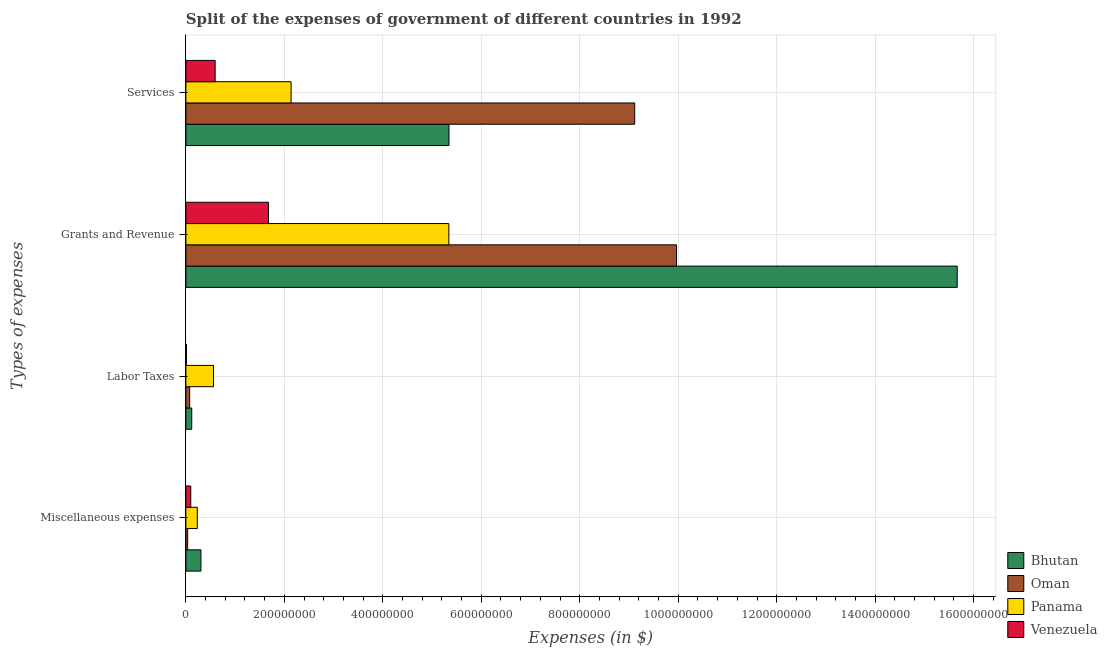How many different coloured bars are there?
Your response must be concise. 4. How many bars are there on the 3rd tick from the top?
Make the answer very short. 4. What is the label of the 2nd group of bars from the top?
Offer a terse response. Grants and Revenue. What is the amount spent on miscellaneous expenses in Bhutan?
Your answer should be compact. 3.06e+07. Across all countries, what is the maximum amount spent on labor taxes?
Give a very brief answer. 5.61e+07. Across all countries, what is the minimum amount spent on services?
Offer a terse response. 5.95e+07. In which country was the amount spent on labor taxes maximum?
Make the answer very short. Panama. In which country was the amount spent on services minimum?
Make the answer very short. Venezuela. What is the total amount spent on miscellaneous expenses in the graph?
Offer a terse response. 6.73e+07. What is the difference between the amount spent on miscellaneous expenses in Panama and that in Venezuela?
Provide a short and direct response. 1.33e+07. What is the difference between the amount spent on miscellaneous expenses in Venezuela and the amount spent on grants and revenue in Panama?
Ensure brevity in your answer.  -5.24e+08. What is the average amount spent on labor taxes per country?
Your answer should be very brief. 1.92e+07. What is the difference between the amount spent on grants and revenue and amount spent on labor taxes in Oman?
Provide a short and direct response. 9.89e+08. In how many countries, is the amount spent on labor taxes greater than 240000000 $?
Keep it short and to the point. 0. What is the ratio of the amount spent on services in Oman to that in Bhutan?
Provide a short and direct response. 1.71. Is the amount spent on grants and revenue in Bhutan less than that in Venezuela?
Keep it short and to the point. No. Is the difference between the amount spent on grants and revenue in Oman and Panama greater than the difference between the amount spent on miscellaneous expenses in Oman and Panama?
Provide a succinct answer. Yes. What is the difference between the highest and the second highest amount spent on labor taxes?
Keep it short and to the point. 4.42e+07. What is the difference between the highest and the lowest amount spent on labor taxes?
Offer a very short reply. 5.49e+07. Is the sum of the amount spent on grants and revenue in Venezuela and Panama greater than the maximum amount spent on labor taxes across all countries?
Your answer should be very brief. Yes. What does the 2nd bar from the top in Services represents?
Your response must be concise. Panama. What does the 1st bar from the bottom in Labor Taxes represents?
Give a very brief answer. Bhutan. Is it the case that in every country, the sum of the amount spent on miscellaneous expenses and amount spent on labor taxes is greater than the amount spent on grants and revenue?
Your answer should be compact. No. How many bars are there?
Make the answer very short. 16. How many countries are there in the graph?
Your response must be concise. 4. Are the values on the major ticks of X-axis written in scientific E-notation?
Make the answer very short. No. Does the graph contain any zero values?
Provide a succinct answer. No. Where does the legend appear in the graph?
Your response must be concise. Bottom right. How many legend labels are there?
Ensure brevity in your answer.  4. How are the legend labels stacked?
Keep it short and to the point. Vertical. What is the title of the graph?
Your answer should be very brief. Split of the expenses of government of different countries in 1992. What is the label or title of the X-axis?
Ensure brevity in your answer.  Expenses (in $). What is the label or title of the Y-axis?
Provide a succinct answer. Types of expenses. What is the Expenses (in $) of Bhutan in Miscellaneous expenses?
Provide a succinct answer. 3.06e+07. What is the Expenses (in $) in Oman in Miscellaneous expenses?
Your response must be concise. 3.60e+06. What is the Expenses (in $) of Panama in Miscellaneous expenses?
Your answer should be very brief. 2.32e+07. What is the Expenses (in $) in Venezuela in Miscellaneous expenses?
Offer a very short reply. 9.93e+06. What is the Expenses (in $) in Bhutan in Labor Taxes?
Your response must be concise. 1.19e+07. What is the Expenses (in $) in Oman in Labor Taxes?
Your answer should be compact. 7.70e+06. What is the Expenses (in $) of Panama in Labor Taxes?
Offer a terse response. 5.61e+07. What is the Expenses (in $) in Venezuela in Labor Taxes?
Your answer should be compact. 1.15e+06. What is the Expenses (in $) in Bhutan in Grants and Revenue?
Provide a short and direct response. 1.57e+09. What is the Expenses (in $) in Oman in Grants and Revenue?
Offer a terse response. 9.96e+08. What is the Expenses (in $) of Panama in Grants and Revenue?
Your answer should be very brief. 5.34e+08. What is the Expenses (in $) in Venezuela in Grants and Revenue?
Make the answer very short. 1.68e+08. What is the Expenses (in $) in Bhutan in Services?
Provide a succinct answer. 5.34e+08. What is the Expenses (in $) of Oman in Services?
Give a very brief answer. 9.12e+08. What is the Expenses (in $) of Panama in Services?
Ensure brevity in your answer.  2.14e+08. What is the Expenses (in $) of Venezuela in Services?
Your response must be concise. 5.95e+07. Across all Types of expenses, what is the maximum Expenses (in $) of Bhutan?
Your answer should be compact. 1.57e+09. Across all Types of expenses, what is the maximum Expenses (in $) in Oman?
Give a very brief answer. 9.96e+08. Across all Types of expenses, what is the maximum Expenses (in $) in Panama?
Provide a short and direct response. 5.34e+08. Across all Types of expenses, what is the maximum Expenses (in $) of Venezuela?
Ensure brevity in your answer.  1.68e+08. Across all Types of expenses, what is the minimum Expenses (in $) of Bhutan?
Offer a terse response. 1.19e+07. Across all Types of expenses, what is the minimum Expenses (in $) of Oman?
Ensure brevity in your answer.  3.60e+06. Across all Types of expenses, what is the minimum Expenses (in $) of Panama?
Make the answer very short. 2.32e+07. Across all Types of expenses, what is the minimum Expenses (in $) in Venezuela?
Make the answer very short. 1.15e+06. What is the total Expenses (in $) in Bhutan in the graph?
Make the answer very short. 2.14e+09. What is the total Expenses (in $) in Oman in the graph?
Give a very brief answer. 1.92e+09. What is the total Expenses (in $) in Panama in the graph?
Your response must be concise. 8.27e+08. What is the total Expenses (in $) of Venezuela in the graph?
Keep it short and to the point. 2.38e+08. What is the difference between the Expenses (in $) in Bhutan in Miscellaneous expenses and that in Labor Taxes?
Your answer should be very brief. 1.87e+07. What is the difference between the Expenses (in $) in Oman in Miscellaneous expenses and that in Labor Taxes?
Your answer should be compact. -4.10e+06. What is the difference between the Expenses (in $) of Panama in Miscellaneous expenses and that in Labor Taxes?
Make the answer very short. -3.29e+07. What is the difference between the Expenses (in $) in Venezuela in Miscellaneous expenses and that in Labor Taxes?
Your answer should be compact. 8.78e+06. What is the difference between the Expenses (in $) of Bhutan in Miscellaneous expenses and that in Grants and Revenue?
Keep it short and to the point. -1.54e+09. What is the difference between the Expenses (in $) in Oman in Miscellaneous expenses and that in Grants and Revenue?
Keep it short and to the point. -9.93e+08. What is the difference between the Expenses (in $) in Panama in Miscellaneous expenses and that in Grants and Revenue?
Make the answer very short. -5.11e+08. What is the difference between the Expenses (in $) of Venezuela in Miscellaneous expenses and that in Grants and Revenue?
Ensure brevity in your answer.  -1.58e+08. What is the difference between the Expenses (in $) of Bhutan in Miscellaneous expenses and that in Services?
Make the answer very short. -5.04e+08. What is the difference between the Expenses (in $) in Oman in Miscellaneous expenses and that in Services?
Provide a short and direct response. -9.08e+08. What is the difference between the Expenses (in $) of Panama in Miscellaneous expenses and that in Services?
Make the answer very short. -1.90e+08. What is the difference between the Expenses (in $) in Venezuela in Miscellaneous expenses and that in Services?
Keep it short and to the point. -4.95e+07. What is the difference between the Expenses (in $) in Bhutan in Labor Taxes and that in Grants and Revenue?
Offer a very short reply. -1.55e+09. What is the difference between the Expenses (in $) of Oman in Labor Taxes and that in Grants and Revenue?
Make the answer very short. -9.89e+08. What is the difference between the Expenses (in $) of Panama in Labor Taxes and that in Grants and Revenue?
Provide a short and direct response. -4.78e+08. What is the difference between the Expenses (in $) in Venezuela in Labor Taxes and that in Grants and Revenue?
Ensure brevity in your answer.  -1.67e+08. What is the difference between the Expenses (in $) of Bhutan in Labor Taxes and that in Services?
Your answer should be very brief. -5.22e+08. What is the difference between the Expenses (in $) in Oman in Labor Taxes and that in Services?
Your answer should be compact. -9.04e+08. What is the difference between the Expenses (in $) of Panama in Labor Taxes and that in Services?
Ensure brevity in your answer.  -1.58e+08. What is the difference between the Expenses (in $) of Venezuela in Labor Taxes and that in Services?
Your answer should be very brief. -5.83e+07. What is the difference between the Expenses (in $) of Bhutan in Grants and Revenue and that in Services?
Keep it short and to the point. 1.03e+09. What is the difference between the Expenses (in $) in Oman in Grants and Revenue and that in Services?
Your answer should be very brief. 8.49e+07. What is the difference between the Expenses (in $) of Panama in Grants and Revenue and that in Services?
Your response must be concise. 3.20e+08. What is the difference between the Expenses (in $) in Venezuela in Grants and Revenue and that in Services?
Offer a terse response. 1.08e+08. What is the difference between the Expenses (in $) in Bhutan in Miscellaneous expenses and the Expenses (in $) in Oman in Labor Taxes?
Keep it short and to the point. 2.29e+07. What is the difference between the Expenses (in $) in Bhutan in Miscellaneous expenses and the Expenses (in $) in Panama in Labor Taxes?
Offer a very short reply. -2.55e+07. What is the difference between the Expenses (in $) in Bhutan in Miscellaneous expenses and the Expenses (in $) in Venezuela in Labor Taxes?
Your answer should be very brief. 2.94e+07. What is the difference between the Expenses (in $) of Oman in Miscellaneous expenses and the Expenses (in $) of Panama in Labor Taxes?
Your response must be concise. -5.25e+07. What is the difference between the Expenses (in $) in Oman in Miscellaneous expenses and the Expenses (in $) in Venezuela in Labor Taxes?
Give a very brief answer. 2.45e+06. What is the difference between the Expenses (in $) in Panama in Miscellaneous expenses and the Expenses (in $) in Venezuela in Labor Taxes?
Make the answer very short. 2.20e+07. What is the difference between the Expenses (in $) of Bhutan in Miscellaneous expenses and the Expenses (in $) of Oman in Grants and Revenue?
Offer a very short reply. -9.66e+08. What is the difference between the Expenses (in $) of Bhutan in Miscellaneous expenses and the Expenses (in $) of Panama in Grants and Revenue?
Provide a short and direct response. -5.04e+08. What is the difference between the Expenses (in $) in Bhutan in Miscellaneous expenses and the Expenses (in $) in Venezuela in Grants and Revenue?
Provide a short and direct response. -1.37e+08. What is the difference between the Expenses (in $) of Oman in Miscellaneous expenses and the Expenses (in $) of Panama in Grants and Revenue?
Provide a succinct answer. -5.30e+08. What is the difference between the Expenses (in $) in Oman in Miscellaneous expenses and the Expenses (in $) in Venezuela in Grants and Revenue?
Offer a very short reply. -1.64e+08. What is the difference between the Expenses (in $) in Panama in Miscellaneous expenses and the Expenses (in $) in Venezuela in Grants and Revenue?
Provide a short and direct response. -1.45e+08. What is the difference between the Expenses (in $) in Bhutan in Miscellaneous expenses and the Expenses (in $) in Oman in Services?
Provide a succinct answer. -8.81e+08. What is the difference between the Expenses (in $) in Bhutan in Miscellaneous expenses and the Expenses (in $) in Panama in Services?
Provide a short and direct response. -1.83e+08. What is the difference between the Expenses (in $) in Bhutan in Miscellaneous expenses and the Expenses (in $) in Venezuela in Services?
Your response must be concise. -2.89e+07. What is the difference between the Expenses (in $) in Oman in Miscellaneous expenses and the Expenses (in $) in Panama in Services?
Ensure brevity in your answer.  -2.10e+08. What is the difference between the Expenses (in $) of Oman in Miscellaneous expenses and the Expenses (in $) of Venezuela in Services?
Your response must be concise. -5.59e+07. What is the difference between the Expenses (in $) in Panama in Miscellaneous expenses and the Expenses (in $) in Venezuela in Services?
Provide a succinct answer. -3.63e+07. What is the difference between the Expenses (in $) of Bhutan in Labor Taxes and the Expenses (in $) of Oman in Grants and Revenue?
Ensure brevity in your answer.  -9.85e+08. What is the difference between the Expenses (in $) in Bhutan in Labor Taxes and the Expenses (in $) in Panama in Grants and Revenue?
Your answer should be compact. -5.22e+08. What is the difference between the Expenses (in $) in Bhutan in Labor Taxes and the Expenses (in $) in Venezuela in Grants and Revenue?
Offer a very short reply. -1.56e+08. What is the difference between the Expenses (in $) of Oman in Labor Taxes and the Expenses (in $) of Panama in Grants and Revenue?
Ensure brevity in your answer.  -5.26e+08. What is the difference between the Expenses (in $) in Oman in Labor Taxes and the Expenses (in $) in Venezuela in Grants and Revenue?
Offer a terse response. -1.60e+08. What is the difference between the Expenses (in $) of Panama in Labor Taxes and the Expenses (in $) of Venezuela in Grants and Revenue?
Give a very brief answer. -1.12e+08. What is the difference between the Expenses (in $) of Bhutan in Labor Taxes and the Expenses (in $) of Oman in Services?
Give a very brief answer. -9.00e+08. What is the difference between the Expenses (in $) in Bhutan in Labor Taxes and the Expenses (in $) in Panama in Services?
Make the answer very short. -2.02e+08. What is the difference between the Expenses (in $) of Bhutan in Labor Taxes and the Expenses (in $) of Venezuela in Services?
Make the answer very short. -4.76e+07. What is the difference between the Expenses (in $) of Oman in Labor Taxes and the Expenses (in $) of Panama in Services?
Your answer should be very brief. -2.06e+08. What is the difference between the Expenses (in $) in Oman in Labor Taxes and the Expenses (in $) in Venezuela in Services?
Offer a very short reply. -5.18e+07. What is the difference between the Expenses (in $) of Panama in Labor Taxes and the Expenses (in $) of Venezuela in Services?
Offer a terse response. -3.36e+06. What is the difference between the Expenses (in $) in Bhutan in Grants and Revenue and the Expenses (in $) in Oman in Services?
Your answer should be compact. 6.55e+08. What is the difference between the Expenses (in $) of Bhutan in Grants and Revenue and the Expenses (in $) of Panama in Services?
Keep it short and to the point. 1.35e+09. What is the difference between the Expenses (in $) of Bhutan in Grants and Revenue and the Expenses (in $) of Venezuela in Services?
Ensure brevity in your answer.  1.51e+09. What is the difference between the Expenses (in $) in Oman in Grants and Revenue and the Expenses (in $) in Panama in Services?
Keep it short and to the point. 7.83e+08. What is the difference between the Expenses (in $) of Oman in Grants and Revenue and the Expenses (in $) of Venezuela in Services?
Give a very brief answer. 9.37e+08. What is the difference between the Expenses (in $) of Panama in Grants and Revenue and the Expenses (in $) of Venezuela in Services?
Make the answer very short. 4.75e+08. What is the average Expenses (in $) of Bhutan per Types of expenses?
Make the answer very short. 5.36e+08. What is the average Expenses (in $) of Oman per Types of expenses?
Provide a short and direct response. 4.80e+08. What is the average Expenses (in $) of Panama per Types of expenses?
Offer a terse response. 2.07e+08. What is the average Expenses (in $) of Venezuela per Types of expenses?
Your answer should be very brief. 5.96e+07. What is the difference between the Expenses (in $) in Bhutan and Expenses (in $) in Oman in Miscellaneous expenses?
Offer a very short reply. 2.70e+07. What is the difference between the Expenses (in $) of Bhutan and Expenses (in $) of Panama in Miscellaneous expenses?
Offer a terse response. 7.40e+06. What is the difference between the Expenses (in $) in Bhutan and Expenses (in $) in Venezuela in Miscellaneous expenses?
Give a very brief answer. 2.07e+07. What is the difference between the Expenses (in $) in Oman and Expenses (in $) in Panama in Miscellaneous expenses?
Keep it short and to the point. -1.96e+07. What is the difference between the Expenses (in $) in Oman and Expenses (in $) in Venezuela in Miscellaneous expenses?
Your response must be concise. -6.33e+06. What is the difference between the Expenses (in $) in Panama and Expenses (in $) in Venezuela in Miscellaneous expenses?
Keep it short and to the point. 1.33e+07. What is the difference between the Expenses (in $) in Bhutan and Expenses (in $) in Oman in Labor Taxes?
Offer a terse response. 4.20e+06. What is the difference between the Expenses (in $) in Bhutan and Expenses (in $) in Panama in Labor Taxes?
Offer a very short reply. -4.42e+07. What is the difference between the Expenses (in $) of Bhutan and Expenses (in $) of Venezuela in Labor Taxes?
Ensure brevity in your answer.  1.07e+07. What is the difference between the Expenses (in $) of Oman and Expenses (in $) of Panama in Labor Taxes?
Offer a terse response. -4.84e+07. What is the difference between the Expenses (in $) of Oman and Expenses (in $) of Venezuela in Labor Taxes?
Offer a very short reply. 6.55e+06. What is the difference between the Expenses (in $) of Panama and Expenses (in $) of Venezuela in Labor Taxes?
Your response must be concise. 5.49e+07. What is the difference between the Expenses (in $) in Bhutan and Expenses (in $) in Oman in Grants and Revenue?
Your answer should be very brief. 5.70e+08. What is the difference between the Expenses (in $) in Bhutan and Expenses (in $) in Panama in Grants and Revenue?
Your answer should be very brief. 1.03e+09. What is the difference between the Expenses (in $) in Bhutan and Expenses (in $) in Venezuela in Grants and Revenue?
Your response must be concise. 1.40e+09. What is the difference between the Expenses (in $) in Oman and Expenses (in $) in Panama in Grants and Revenue?
Provide a short and direct response. 4.62e+08. What is the difference between the Expenses (in $) of Oman and Expenses (in $) of Venezuela in Grants and Revenue?
Offer a very short reply. 8.29e+08. What is the difference between the Expenses (in $) in Panama and Expenses (in $) in Venezuela in Grants and Revenue?
Provide a succinct answer. 3.66e+08. What is the difference between the Expenses (in $) of Bhutan and Expenses (in $) of Oman in Services?
Offer a very short reply. -3.77e+08. What is the difference between the Expenses (in $) in Bhutan and Expenses (in $) in Panama in Services?
Keep it short and to the point. 3.21e+08. What is the difference between the Expenses (in $) of Bhutan and Expenses (in $) of Venezuela in Services?
Offer a very short reply. 4.75e+08. What is the difference between the Expenses (in $) of Oman and Expenses (in $) of Panama in Services?
Provide a succinct answer. 6.98e+08. What is the difference between the Expenses (in $) of Oman and Expenses (in $) of Venezuela in Services?
Provide a succinct answer. 8.52e+08. What is the difference between the Expenses (in $) of Panama and Expenses (in $) of Venezuela in Services?
Provide a succinct answer. 1.54e+08. What is the ratio of the Expenses (in $) of Bhutan in Miscellaneous expenses to that in Labor Taxes?
Offer a very short reply. 2.57. What is the ratio of the Expenses (in $) in Oman in Miscellaneous expenses to that in Labor Taxes?
Offer a very short reply. 0.47. What is the ratio of the Expenses (in $) of Panama in Miscellaneous expenses to that in Labor Taxes?
Give a very brief answer. 0.41. What is the ratio of the Expenses (in $) of Venezuela in Miscellaneous expenses to that in Labor Taxes?
Offer a terse response. 8.62. What is the ratio of the Expenses (in $) in Bhutan in Miscellaneous expenses to that in Grants and Revenue?
Keep it short and to the point. 0.02. What is the ratio of the Expenses (in $) in Oman in Miscellaneous expenses to that in Grants and Revenue?
Your response must be concise. 0. What is the ratio of the Expenses (in $) in Panama in Miscellaneous expenses to that in Grants and Revenue?
Make the answer very short. 0.04. What is the ratio of the Expenses (in $) of Venezuela in Miscellaneous expenses to that in Grants and Revenue?
Your answer should be compact. 0.06. What is the ratio of the Expenses (in $) in Bhutan in Miscellaneous expenses to that in Services?
Your response must be concise. 0.06. What is the ratio of the Expenses (in $) of Oman in Miscellaneous expenses to that in Services?
Offer a very short reply. 0. What is the ratio of the Expenses (in $) of Panama in Miscellaneous expenses to that in Services?
Your answer should be very brief. 0.11. What is the ratio of the Expenses (in $) of Venezuela in Miscellaneous expenses to that in Services?
Your response must be concise. 0.17. What is the ratio of the Expenses (in $) of Bhutan in Labor Taxes to that in Grants and Revenue?
Provide a succinct answer. 0.01. What is the ratio of the Expenses (in $) in Oman in Labor Taxes to that in Grants and Revenue?
Your answer should be very brief. 0.01. What is the ratio of the Expenses (in $) in Panama in Labor Taxes to that in Grants and Revenue?
Provide a short and direct response. 0.1. What is the ratio of the Expenses (in $) in Venezuela in Labor Taxes to that in Grants and Revenue?
Offer a terse response. 0.01. What is the ratio of the Expenses (in $) of Bhutan in Labor Taxes to that in Services?
Give a very brief answer. 0.02. What is the ratio of the Expenses (in $) of Oman in Labor Taxes to that in Services?
Your answer should be very brief. 0.01. What is the ratio of the Expenses (in $) of Panama in Labor Taxes to that in Services?
Provide a succinct answer. 0.26. What is the ratio of the Expenses (in $) of Venezuela in Labor Taxes to that in Services?
Your answer should be compact. 0.02. What is the ratio of the Expenses (in $) in Bhutan in Grants and Revenue to that in Services?
Provide a succinct answer. 2.93. What is the ratio of the Expenses (in $) of Oman in Grants and Revenue to that in Services?
Ensure brevity in your answer.  1.09. What is the ratio of the Expenses (in $) of Panama in Grants and Revenue to that in Services?
Keep it short and to the point. 2.5. What is the ratio of the Expenses (in $) of Venezuela in Grants and Revenue to that in Services?
Give a very brief answer. 2.82. What is the difference between the highest and the second highest Expenses (in $) in Bhutan?
Make the answer very short. 1.03e+09. What is the difference between the highest and the second highest Expenses (in $) in Oman?
Offer a terse response. 8.49e+07. What is the difference between the highest and the second highest Expenses (in $) in Panama?
Your answer should be compact. 3.20e+08. What is the difference between the highest and the second highest Expenses (in $) of Venezuela?
Ensure brevity in your answer.  1.08e+08. What is the difference between the highest and the lowest Expenses (in $) of Bhutan?
Your response must be concise. 1.55e+09. What is the difference between the highest and the lowest Expenses (in $) of Oman?
Your response must be concise. 9.93e+08. What is the difference between the highest and the lowest Expenses (in $) of Panama?
Ensure brevity in your answer.  5.11e+08. What is the difference between the highest and the lowest Expenses (in $) of Venezuela?
Provide a succinct answer. 1.67e+08. 